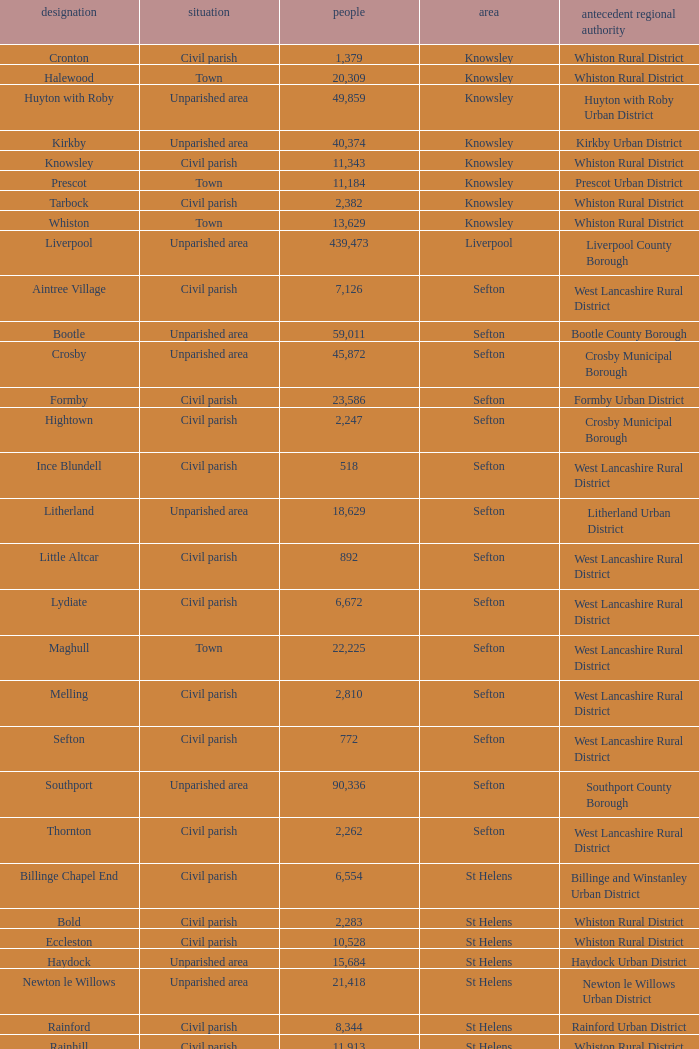What is the district of wallasey Wirral. 